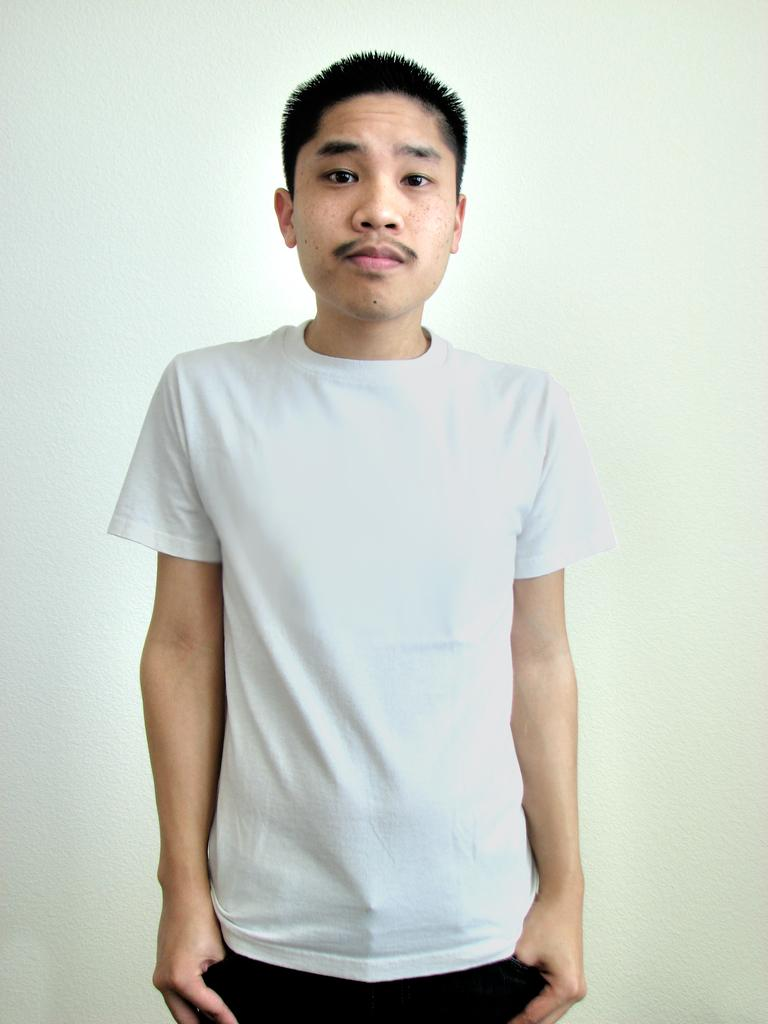What is the main subject of the image? There is a person standing in the image. What type of stitch is being used to create the cart in the image? There is no stitch or cart present in the image; it features a person standing. 